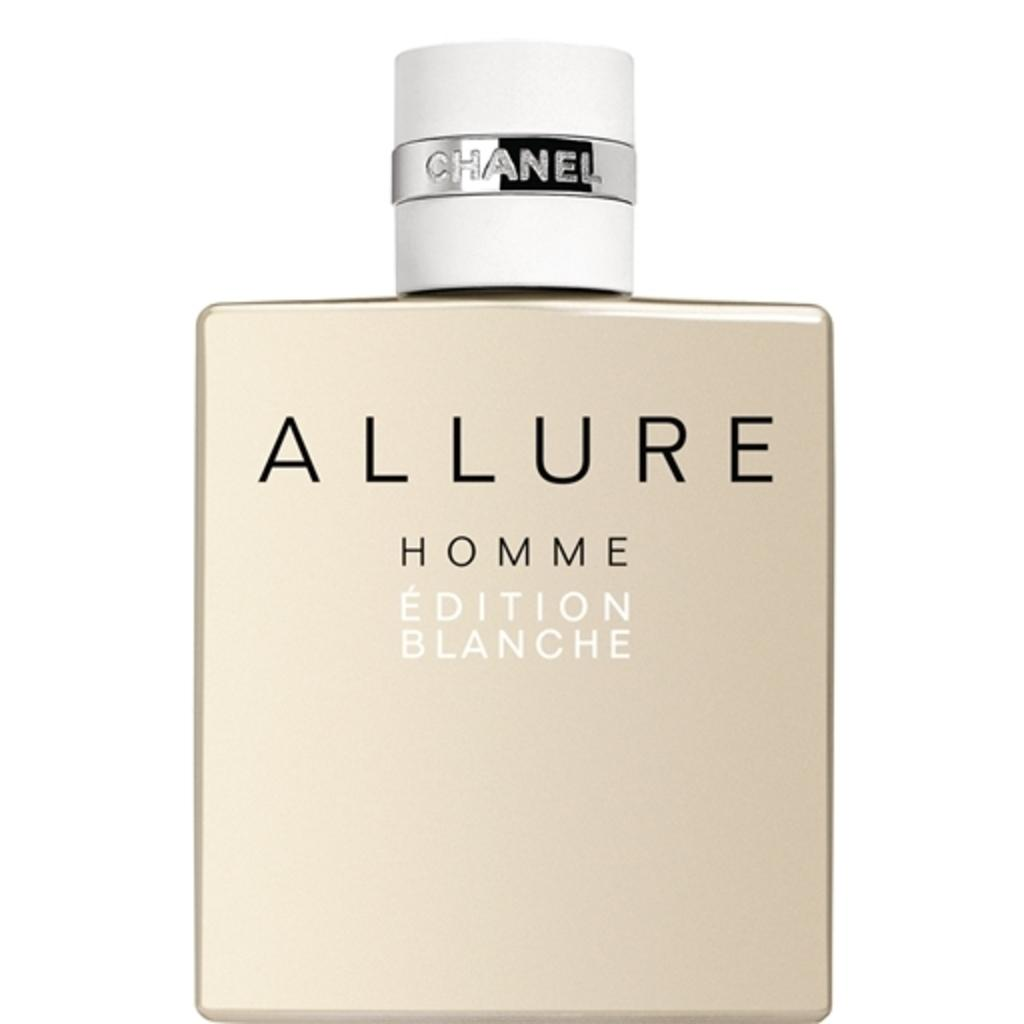<image>
Summarize the visual content of the image. A Chanel bottle of Allure fragrance is shown with "Homme Edition Blanche" on it. 